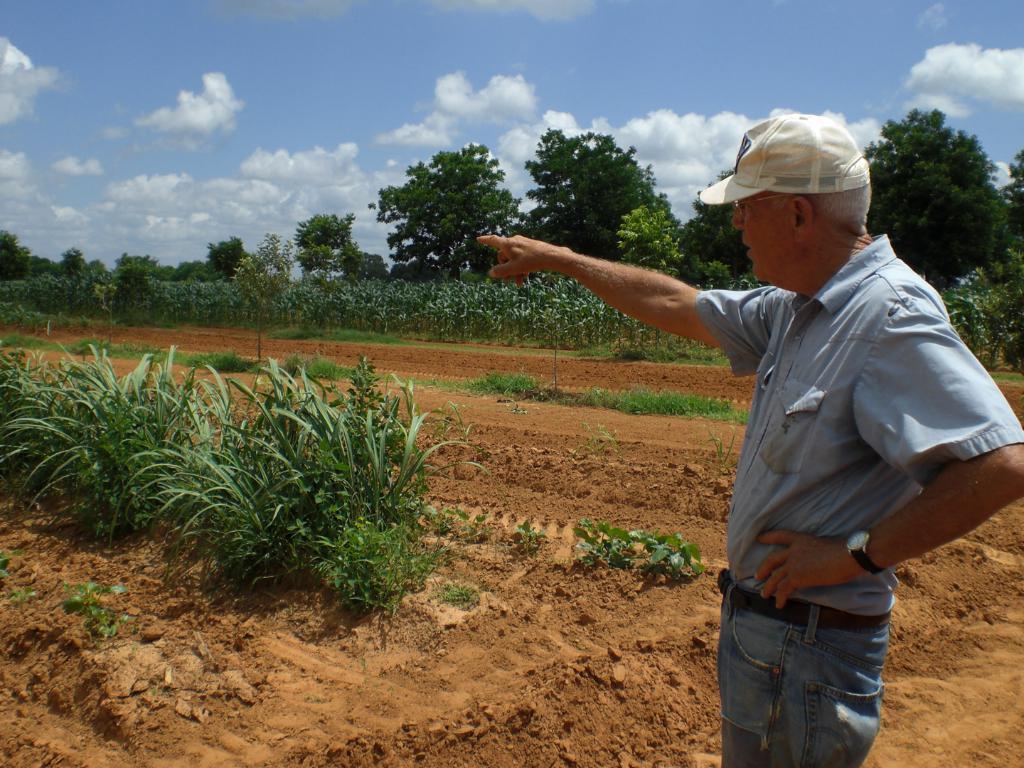Describe this image in one or two sentences. In this image I can see on the right side a man is standing and pointing his hand towards the left side. He is wearing the cap, on the left side there are plants, in the background there are trees. At the top there is the sky. 